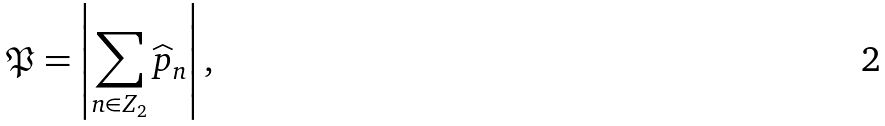Convert formula to latex. <formula><loc_0><loc_0><loc_500><loc_500>\mathfrak { P } = \left | \sum _ { n \in Z _ { 2 } } \widehat { p } _ { n } \right | ,</formula> 